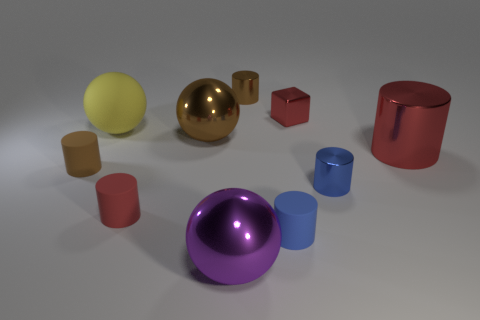The metal object that is the same color as the shiny block is what shape?
Keep it short and to the point. Cylinder. What size is the rubber object that is the same color as the small cube?
Your answer should be very brief. Small. There is a brown cylinder that is in front of the big red metallic cylinder; does it have the same size as the brown cylinder that is to the right of the large purple metallic ball?
Offer a terse response. Yes. What number of blocks are either small green things or big red metallic objects?
Offer a very short reply. 0. How many metallic things are either yellow balls or large brown spheres?
Give a very brief answer. 1. There is another red object that is the same shape as the small red matte thing; what size is it?
Offer a terse response. Large. Is there any other thing that is the same size as the purple object?
Your answer should be compact. Yes. Do the purple metal object and the red cylinder left of the tiny metallic cube have the same size?
Provide a short and direct response. No. The large shiny object left of the purple metallic object has what shape?
Offer a very short reply. Sphere. What is the color of the large shiny sphere that is left of the metallic ball that is in front of the blue metallic thing?
Give a very brief answer. Brown. 